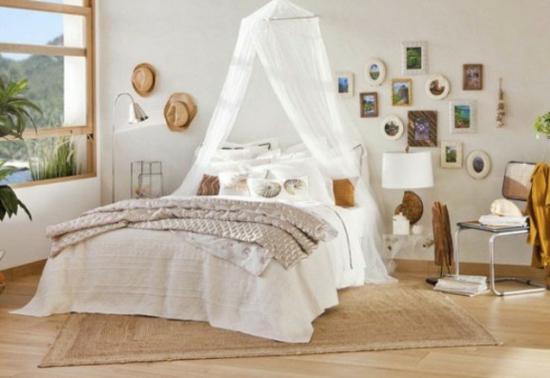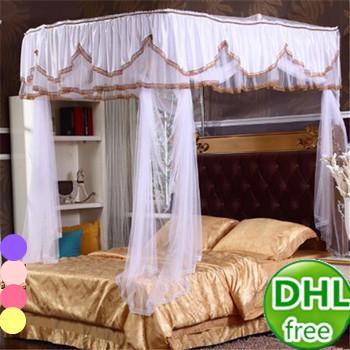The first image is the image on the left, the second image is the image on the right. Given the left and right images, does the statement "Each bed is covered by a white canape." hold true? Answer yes or no. Yes. 